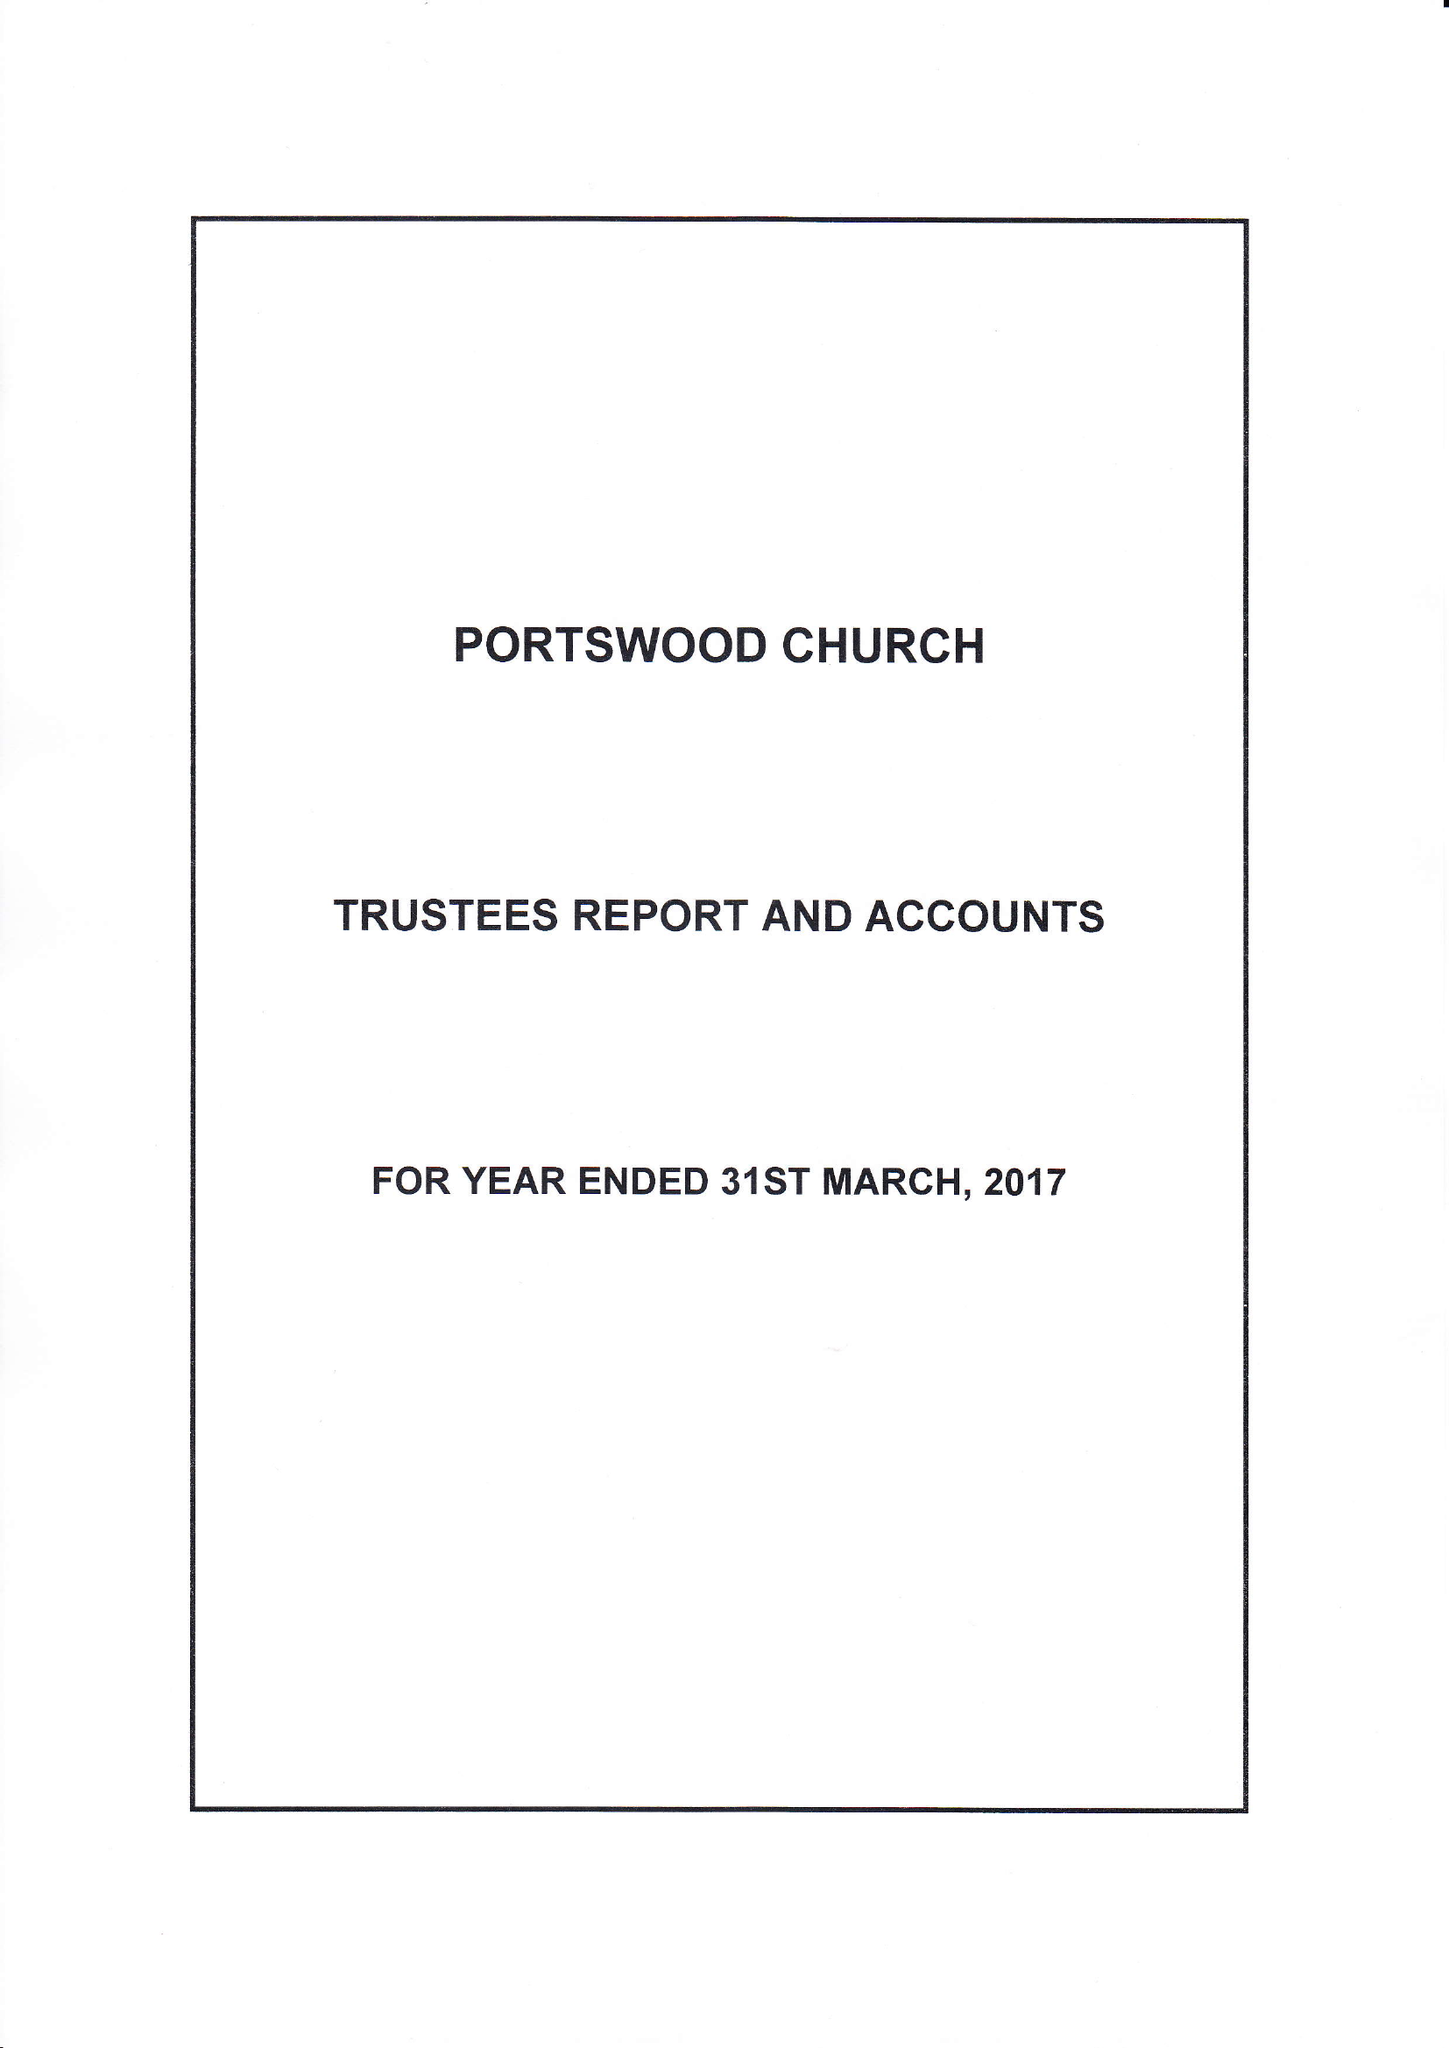What is the value for the income_annually_in_british_pounds?
Answer the question using a single word or phrase. 262436.00 